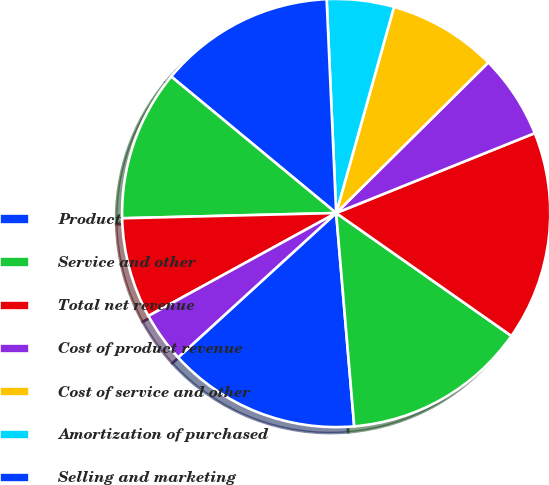<chart> <loc_0><loc_0><loc_500><loc_500><pie_chart><fcel>Product<fcel>Service and other<fcel>Total net revenue<fcel>Cost of product revenue<fcel>Cost of service and other<fcel>Amortization of purchased<fcel>Selling and marketing<fcel>Research and development<fcel>General and administrative<fcel>Acquisition-related charges<nl><fcel>14.56%<fcel>13.92%<fcel>15.82%<fcel>6.33%<fcel>8.23%<fcel>5.06%<fcel>13.29%<fcel>11.39%<fcel>7.59%<fcel>3.8%<nl></chart> 